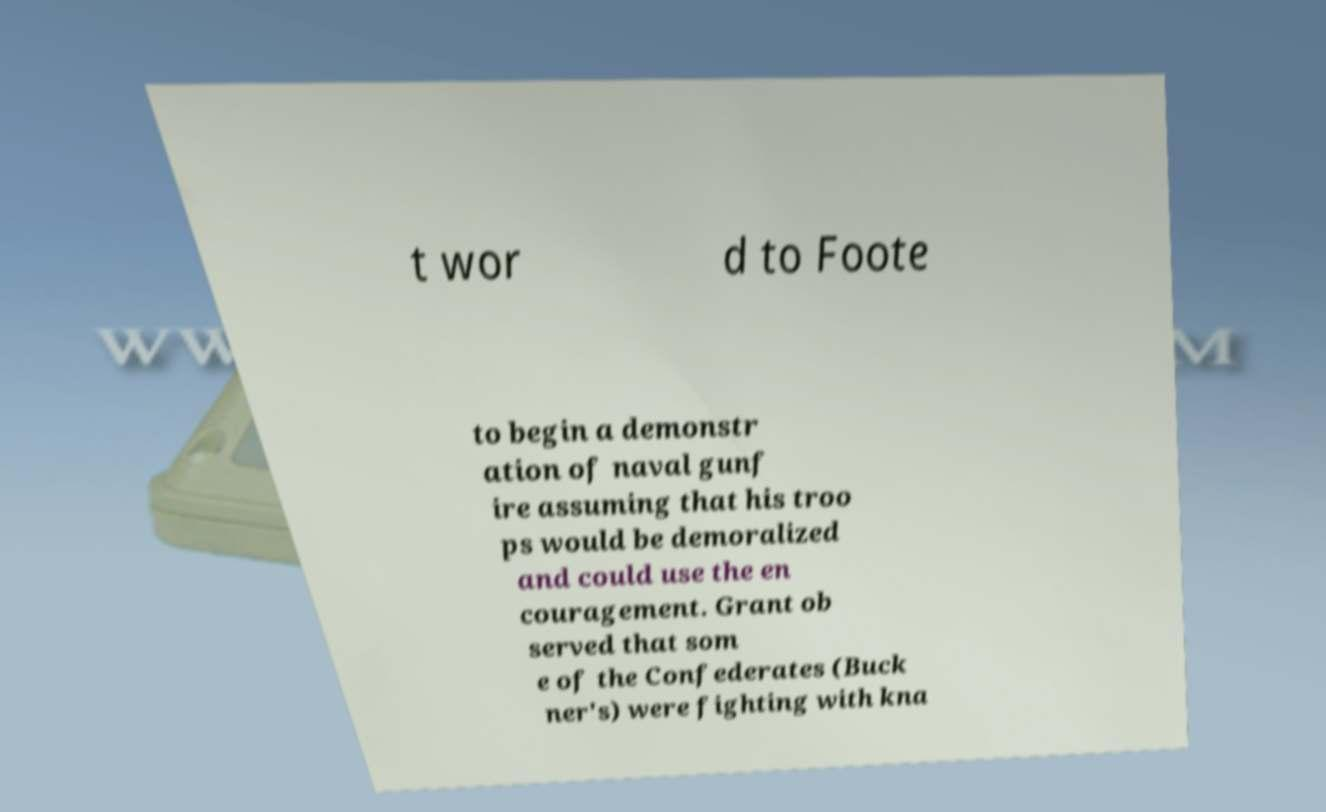I need the written content from this picture converted into text. Can you do that? t wor d to Foote to begin a demonstr ation of naval gunf ire assuming that his troo ps would be demoralized and could use the en couragement. Grant ob served that som e of the Confederates (Buck ner's) were fighting with kna 